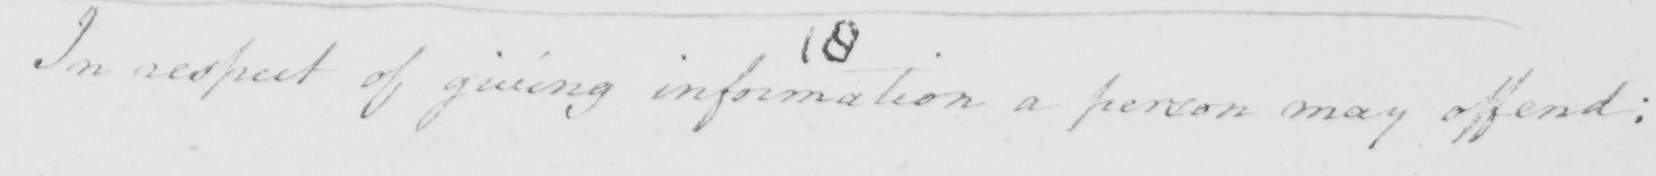Please provide the text content of this handwritten line. In respect of giving information a person may offend : 